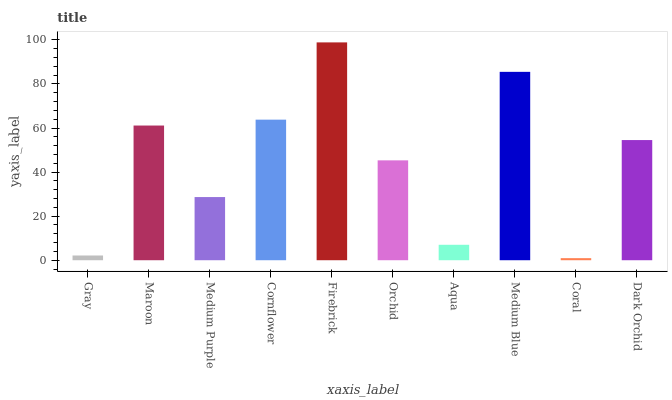Is Coral the minimum?
Answer yes or no. Yes. Is Firebrick the maximum?
Answer yes or no. Yes. Is Maroon the minimum?
Answer yes or no. No. Is Maroon the maximum?
Answer yes or no. No. Is Maroon greater than Gray?
Answer yes or no. Yes. Is Gray less than Maroon?
Answer yes or no. Yes. Is Gray greater than Maroon?
Answer yes or no. No. Is Maroon less than Gray?
Answer yes or no. No. Is Dark Orchid the high median?
Answer yes or no. Yes. Is Orchid the low median?
Answer yes or no. Yes. Is Medium Purple the high median?
Answer yes or no. No. Is Medium Purple the low median?
Answer yes or no. No. 